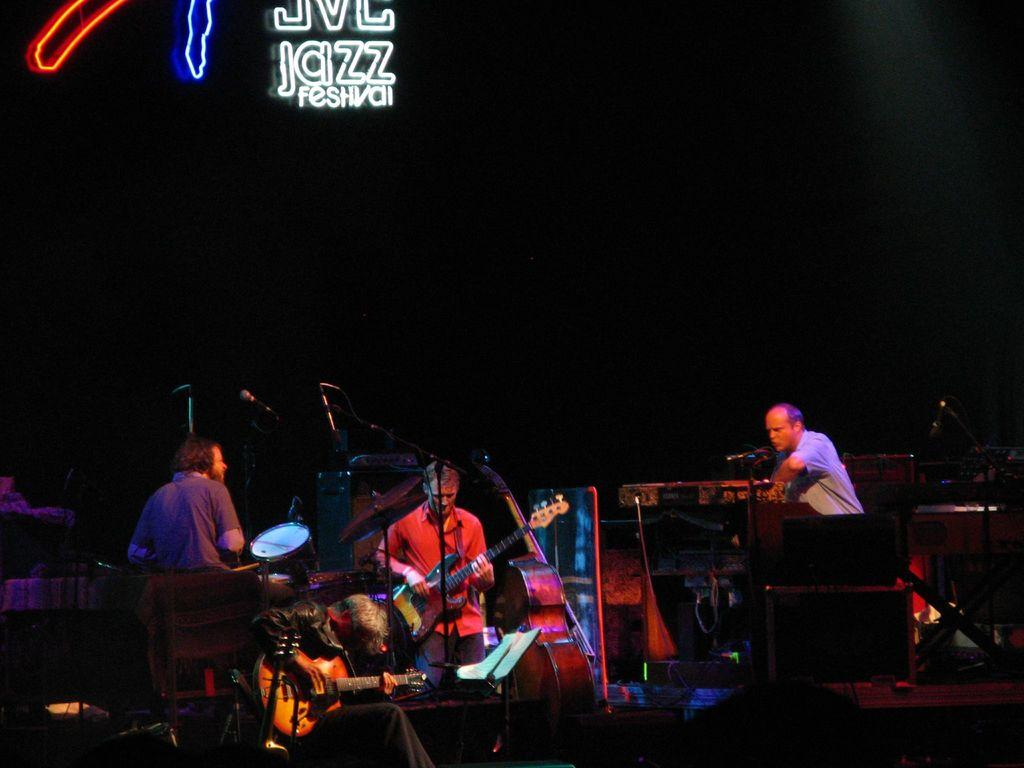What event is happening in the image? A musical concert is taking place. What are the musicians doing during the concert? The musicians are playing music systems. How can you describe the lighting in the image? The background is dark. What type of festival is suggested by the phrase written at the top of the image? The phrase "jazz festival" suggests that it is a jazz music festival. How many fish can be seen swimming in the background of the image? There are no fish visible in the image, as it features a musical concert with musicians playing music systems. What type of umbrella is being used by the musicians to protect themselves from the rain? There is no umbrella present in the image, and it is not raining. 